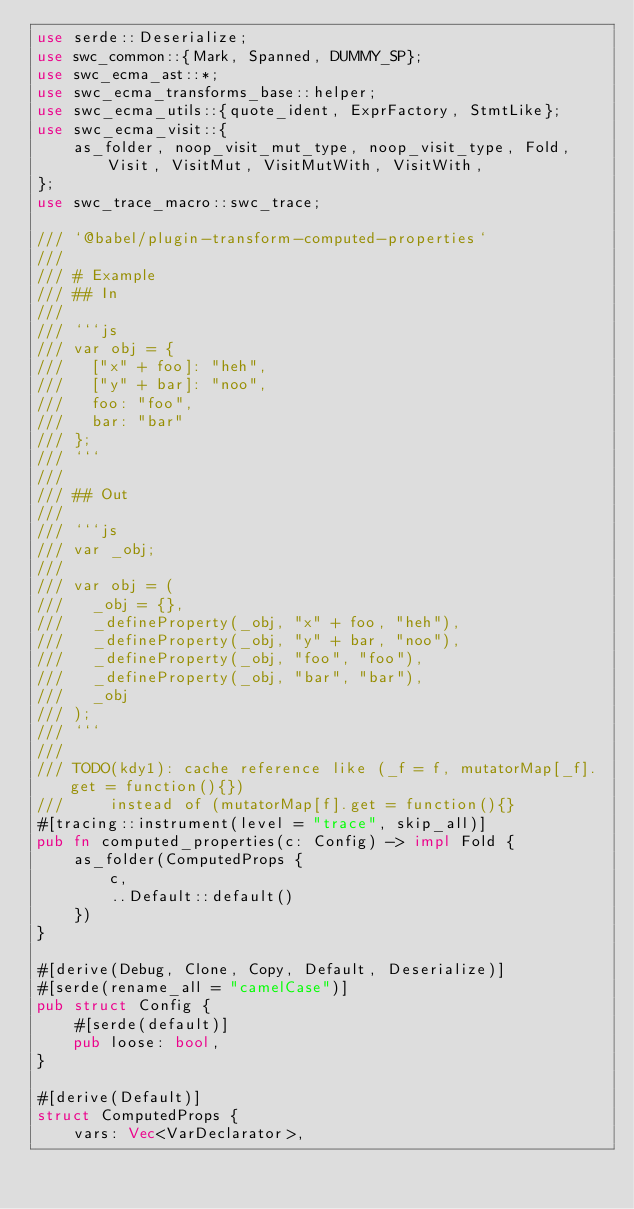<code> <loc_0><loc_0><loc_500><loc_500><_Rust_>use serde::Deserialize;
use swc_common::{Mark, Spanned, DUMMY_SP};
use swc_ecma_ast::*;
use swc_ecma_transforms_base::helper;
use swc_ecma_utils::{quote_ident, ExprFactory, StmtLike};
use swc_ecma_visit::{
    as_folder, noop_visit_mut_type, noop_visit_type, Fold, Visit, VisitMut, VisitMutWith, VisitWith,
};
use swc_trace_macro::swc_trace;

/// `@babel/plugin-transform-computed-properties`
///
/// # Example
/// ## In
///
/// ```js
/// var obj = {
///   ["x" + foo]: "heh",
///   ["y" + bar]: "noo",
///   foo: "foo",
///   bar: "bar"
/// };
/// ```
///
/// ## Out
///
/// ```js
/// var _obj;
///
/// var obj = (
///   _obj = {},
///   _defineProperty(_obj, "x" + foo, "heh"),
///   _defineProperty(_obj, "y" + bar, "noo"),
///   _defineProperty(_obj, "foo", "foo"),
///   _defineProperty(_obj, "bar", "bar"),
///   _obj
/// );
/// ```
///
/// TODO(kdy1): cache reference like (_f = f, mutatorMap[_f].get = function(){})
///     instead of (mutatorMap[f].get = function(){}
#[tracing::instrument(level = "trace", skip_all)]
pub fn computed_properties(c: Config) -> impl Fold {
    as_folder(ComputedProps {
        c,
        ..Default::default()
    })
}

#[derive(Debug, Clone, Copy, Default, Deserialize)]
#[serde(rename_all = "camelCase")]
pub struct Config {
    #[serde(default)]
    pub loose: bool,
}

#[derive(Default)]
struct ComputedProps {
    vars: Vec<VarDeclarator>,</code> 